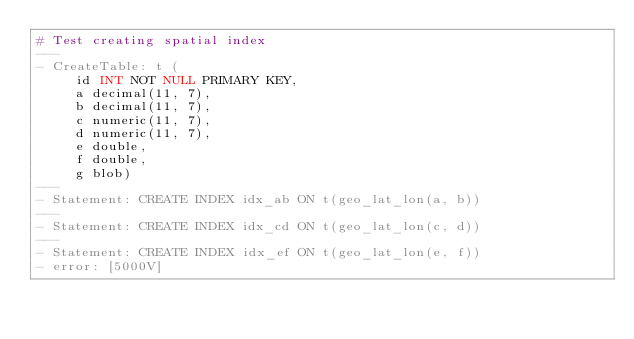Convert code to text. <code><loc_0><loc_0><loc_500><loc_500><_YAML_># Test creating spatial index
---
- CreateTable: t (
     id INT NOT NULL PRIMARY KEY,
     a decimal(11, 7),
     b decimal(11, 7),
     c numeric(11, 7),
     d numeric(11, 7),
     e double,
     f double,
     g blob)
---
- Statement: CREATE INDEX idx_ab ON t(geo_lat_lon(a, b))
---
- Statement: CREATE INDEX idx_cd ON t(geo_lat_lon(c, d))
---
- Statement: CREATE INDEX idx_ef ON t(geo_lat_lon(e, f))
- error: [5000V]
</code> 